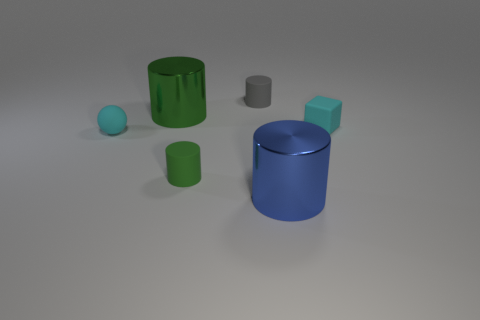What material is the small object that is the same color as the rubber block?
Offer a terse response. Rubber. There is a big metal object that is on the right side of the green matte thing; does it have the same shape as the tiny matte object that is in front of the cyan ball?
Give a very brief answer. Yes. The small object that is the same color as the rubber ball is what shape?
Offer a very short reply. Cube. How many cyan balls are made of the same material as the big blue thing?
Keep it short and to the point. 0. The thing that is both on the left side of the green rubber thing and in front of the large green metallic thing has what shape?
Make the answer very short. Sphere. Do the green cylinder that is left of the green rubber cylinder and the blue object have the same material?
Offer a very short reply. Yes. There is a matte sphere that is the same size as the cyan matte block; what color is it?
Provide a short and direct response. Cyan. Are there any matte blocks of the same color as the matte ball?
Ensure brevity in your answer.  Yes. What is the size of the blue cylinder that is the same material as the big green object?
Give a very brief answer. Large. What number of other objects are the same size as the gray thing?
Offer a very short reply. 3. 